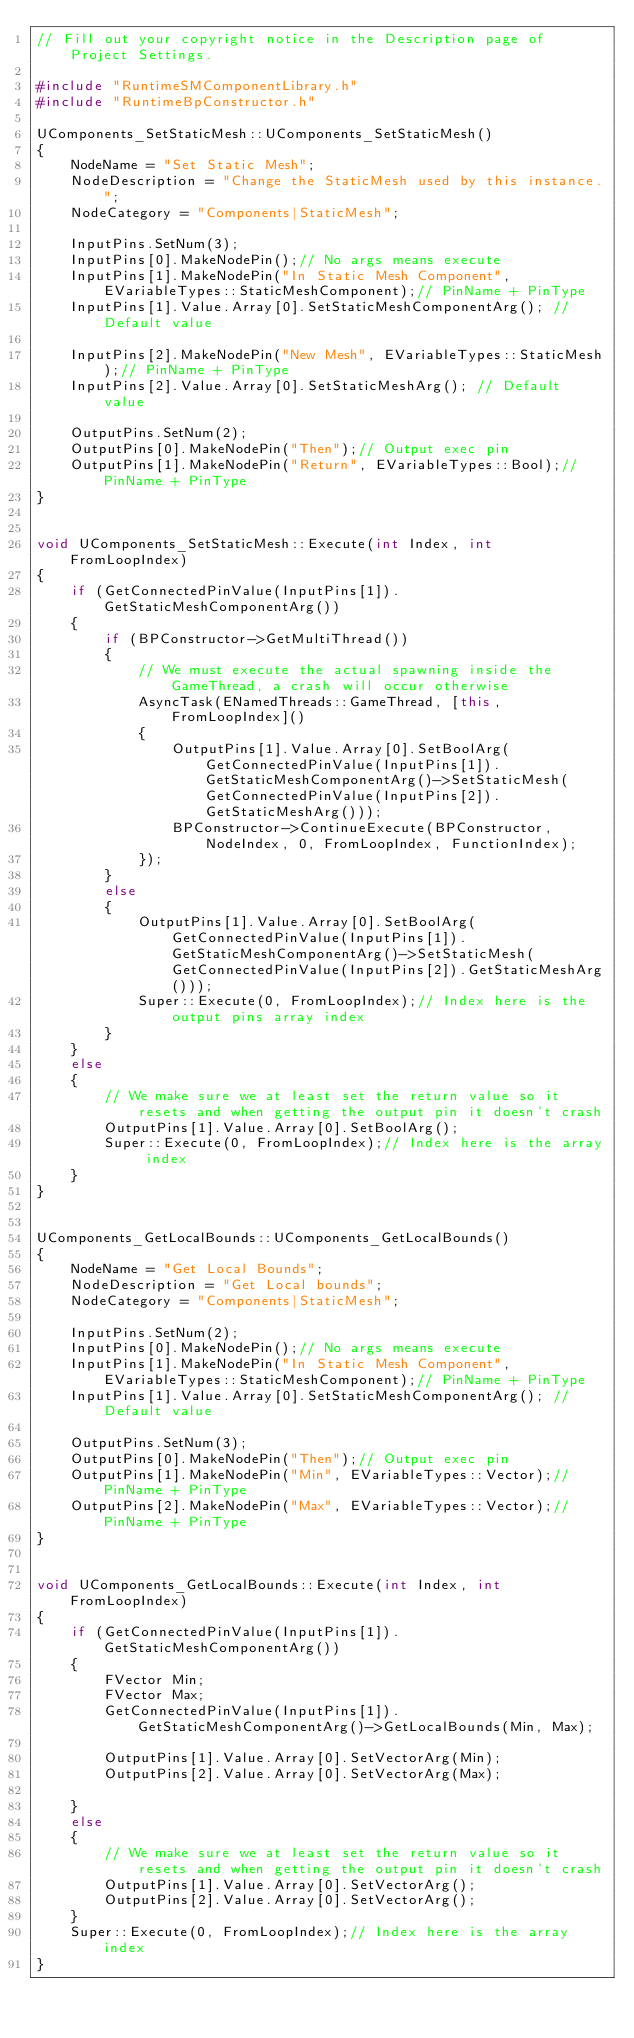<code> <loc_0><loc_0><loc_500><loc_500><_C++_>// Fill out your copyright notice in the Description page of Project Settings.

#include "RuntimeSMComponentLibrary.h"
#include "RuntimeBpConstructor.h"

UComponents_SetStaticMesh::UComponents_SetStaticMesh()
{
	NodeName = "Set Static Mesh";
	NodeDescription = "Change the StaticMesh used by this instance.";
	NodeCategory = "Components|StaticMesh";
	
	InputPins.SetNum(3); 
	InputPins[0].MakeNodePin();// No args means execute
	InputPins[1].MakeNodePin("In Static Mesh Component", EVariableTypes::StaticMeshComponent);// PinName + PinType
	InputPins[1].Value.Array[0].SetStaticMeshComponentArg(); // Default value

	InputPins[2].MakeNodePin("New Mesh", EVariableTypes::StaticMesh);// PinName + PinType
	InputPins[2].Value.Array[0].SetStaticMeshArg(); // Default value

	OutputPins.SetNum(2);
	OutputPins[0].MakeNodePin("Then");// Output exec pin    
    OutputPins[1].MakeNodePin("Return", EVariableTypes::Bool);// PinName + PinType
}


void UComponents_SetStaticMesh::Execute(int Index, int FromLoopIndex)
{
	if (GetConnectedPinValue(InputPins[1]).GetStaticMeshComponentArg())
	{
		if (BPConstructor->GetMultiThread())
		{
			// We must execute the actual spawning inside the GameThread, a crash will occur otherwise
			AsyncTask(ENamedThreads::GameThread, [this, FromLoopIndex]()
			{
				OutputPins[1].Value.Array[0].SetBoolArg(GetConnectedPinValue(InputPins[1]).GetStaticMeshComponentArg()->SetStaticMesh(GetConnectedPinValue(InputPins[2]).GetStaticMeshArg()));
				BPConstructor->ContinueExecute(BPConstructor, NodeIndex, 0, FromLoopIndex, FunctionIndex);
			});
		}
		else
		{
			OutputPins[1].Value.Array[0].SetBoolArg(GetConnectedPinValue(InputPins[1]).GetStaticMeshComponentArg()->SetStaticMesh(GetConnectedPinValue(InputPins[2]).GetStaticMeshArg()));
			Super::Execute(0, FromLoopIndex);// Index here is the output pins array index
		}
	}
	else
	{
		// We make sure we at least set the return value so it resets and when getting the output pin it doesn't crash
		OutputPins[1].Value.Array[0].SetBoolArg();
		Super::Execute(0, FromLoopIndex);// Index here is the array index
	}
}


UComponents_GetLocalBounds::UComponents_GetLocalBounds()
{
	NodeName = "Get Local Bounds";
	NodeDescription = "Get Local bounds";
	NodeCategory = "Components|StaticMesh";
	
	InputPins.SetNum(2); 
	InputPins[0].MakeNodePin();// No args means execute
	InputPins[1].MakeNodePin("In Static Mesh Component", EVariableTypes::StaticMeshComponent);// PinName + PinType
	InputPins[1].Value.Array[0].SetStaticMeshComponentArg(); // Default value

	OutputPins.SetNum(3);
	OutputPins[0].MakeNodePin("Then");// Output exec pin    
    OutputPins[1].MakeNodePin("Min", EVariableTypes::Vector);// PinName + PinType    
    OutputPins[2].MakeNodePin("Max", EVariableTypes::Vector);// PinName + PinType
}


void UComponents_GetLocalBounds::Execute(int Index, int FromLoopIndex)
{
    if (GetConnectedPinValue(InputPins[1]).GetStaticMeshComponentArg())
    {
        FVector Min;
		FVector Max;
		GetConnectedPinValue(InputPins[1]).GetStaticMeshComponentArg()->GetLocalBounds(Min, Max);
         
		OutputPins[1].Value.Array[0].SetVectorArg(Min);
		OutputPins[2].Value.Array[0].SetVectorArg(Max);

    }
    else
    {
        // We make sure we at least set the return value so it resets and when getting the output pin it doesn't crash
		OutputPins[1].Value.Array[0].SetVectorArg();
		OutputPins[2].Value.Array[0].SetVectorArg();
    }
	Super::Execute(0, FromLoopIndex);// Index here is the array index
}

</code> 